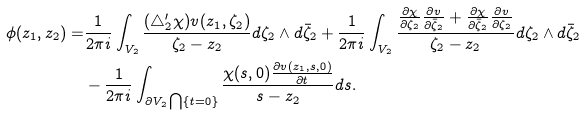Convert formula to latex. <formula><loc_0><loc_0><loc_500><loc_500>\phi ( z _ { 1 } , z _ { 2 } ) = & \frac { 1 } { 2 \pi i } \int _ { V _ { 2 } } \frac { ( \triangle _ { 2 } ^ { \prime } \chi ) v ( z _ { 1 } , \zeta _ { 2 } ) } { \zeta _ { 2 } - z _ { 2 } } d \zeta _ { 2 } \wedge d \bar { \zeta } _ { 2 } + \frac { 1 } { 2 \pi i } \int _ { V _ { 2 } } \frac { \frac { \partial \chi } { \partial \zeta _ { 2 } } \frac { \partial v } { \partial \bar { \zeta } _ { 2 } } + \frac { \partial \chi } { \partial \bar { \zeta } _ { 2 } } \frac { \partial v } { \partial \zeta _ { 2 } } } { \zeta _ { 2 } - z _ { 2 } } d \zeta _ { 2 } \wedge d \bar { \zeta } _ { 2 } \\ & - \frac { 1 } { 2 \pi i } \int _ { \partial V _ { 2 } \bigcap \{ t = 0 \} } \frac { \chi ( s , 0 ) \frac { \partial v ( z _ { 1 } , s , 0 ) } { \partial t } } { s - z _ { 2 } } d s .</formula> 